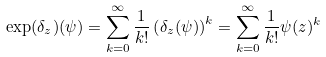<formula> <loc_0><loc_0><loc_500><loc_500>\exp ( \delta _ { z } ) ( \psi ) = \sum _ { k = 0 } ^ { \infty } \frac { 1 } { k ! } \left ( \delta _ { z } ( \psi ) \right ) ^ { k } = \sum _ { k = 0 } ^ { \infty } \frac { 1 } { k ! } \psi ( z ) ^ { k }</formula> 